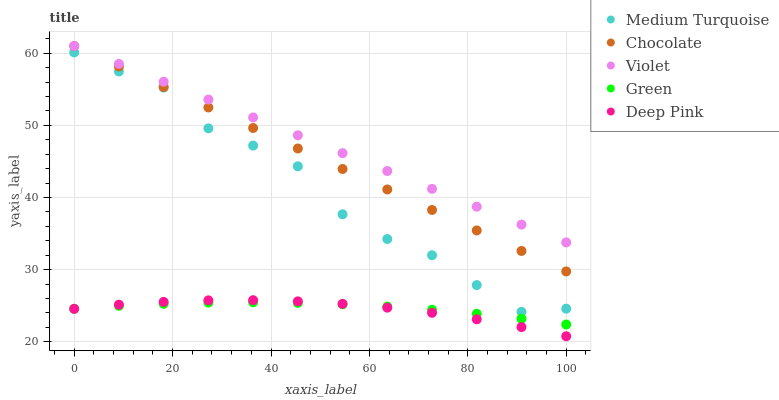Does Deep Pink have the minimum area under the curve?
Answer yes or no. Yes. Does Violet have the maximum area under the curve?
Answer yes or no. Yes. Does Green have the minimum area under the curve?
Answer yes or no. No. Does Green have the maximum area under the curve?
Answer yes or no. No. Is Violet the smoothest?
Answer yes or no. Yes. Is Medium Turquoise the roughest?
Answer yes or no. Yes. Is Green the smoothest?
Answer yes or no. No. Is Green the roughest?
Answer yes or no. No. Does Deep Pink have the lowest value?
Answer yes or no. Yes. Does Green have the lowest value?
Answer yes or no. No. Does Chocolate have the highest value?
Answer yes or no. Yes. Does Deep Pink have the highest value?
Answer yes or no. No. Is Deep Pink less than Medium Turquoise?
Answer yes or no. Yes. Is Violet greater than Medium Turquoise?
Answer yes or no. Yes. Does Green intersect Deep Pink?
Answer yes or no. Yes. Is Green less than Deep Pink?
Answer yes or no. No. Is Green greater than Deep Pink?
Answer yes or no. No. Does Deep Pink intersect Medium Turquoise?
Answer yes or no. No. 